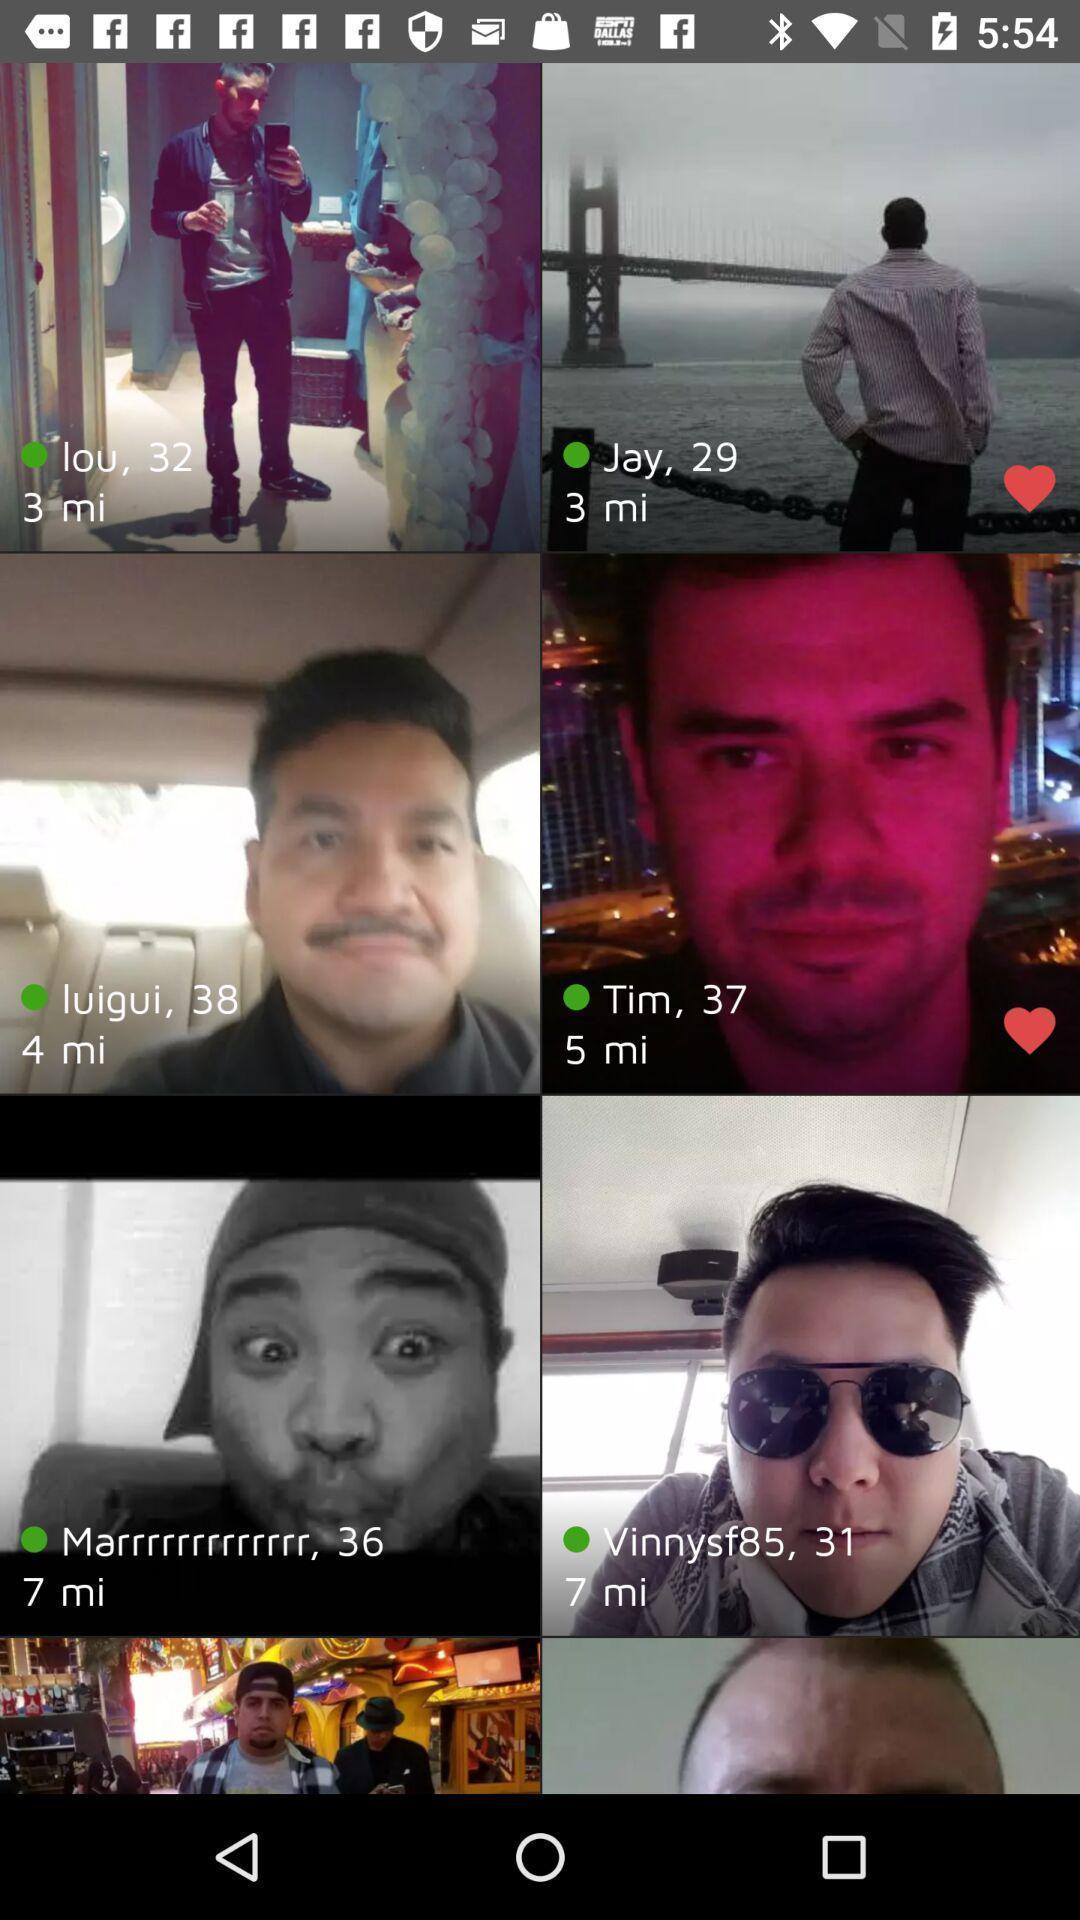Provide a description of this screenshot. Screen displaying page of an social application. 